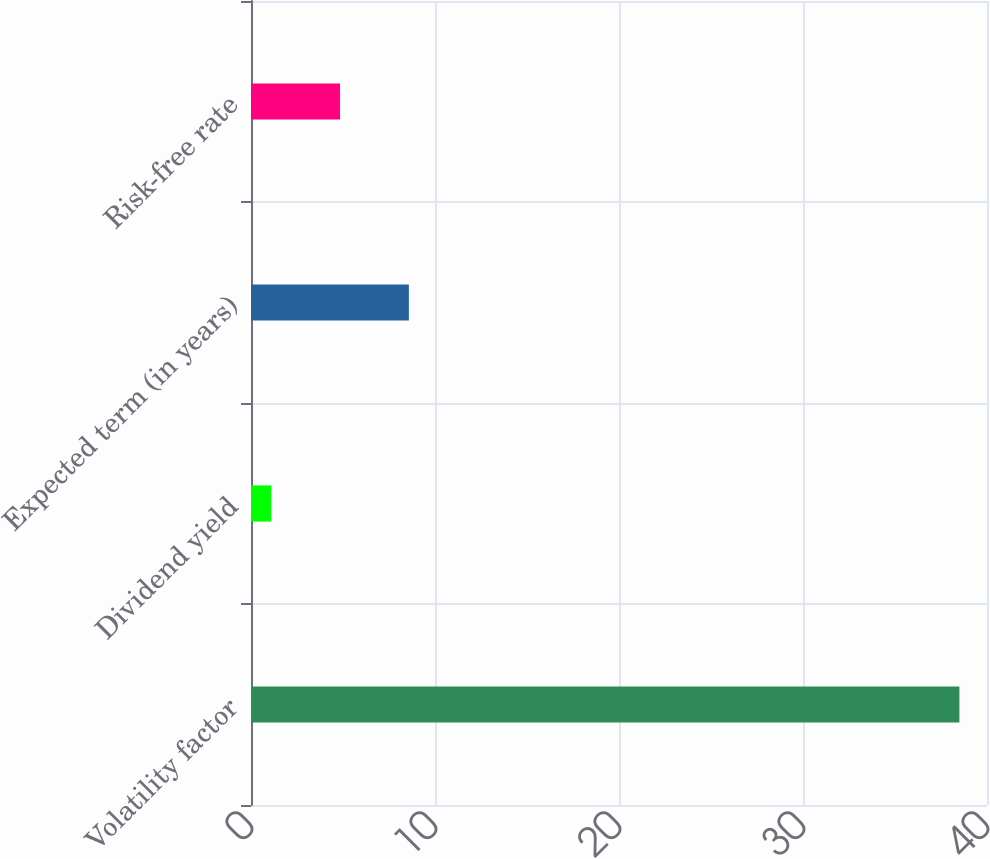Convert chart. <chart><loc_0><loc_0><loc_500><loc_500><bar_chart><fcel>Volatility factor<fcel>Dividend yield<fcel>Expected term (in years)<fcel>Risk-free rate<nl><fcel>38.5<fcel>1.1<fcel>8.58<fcel>4.84<nl></chart> 